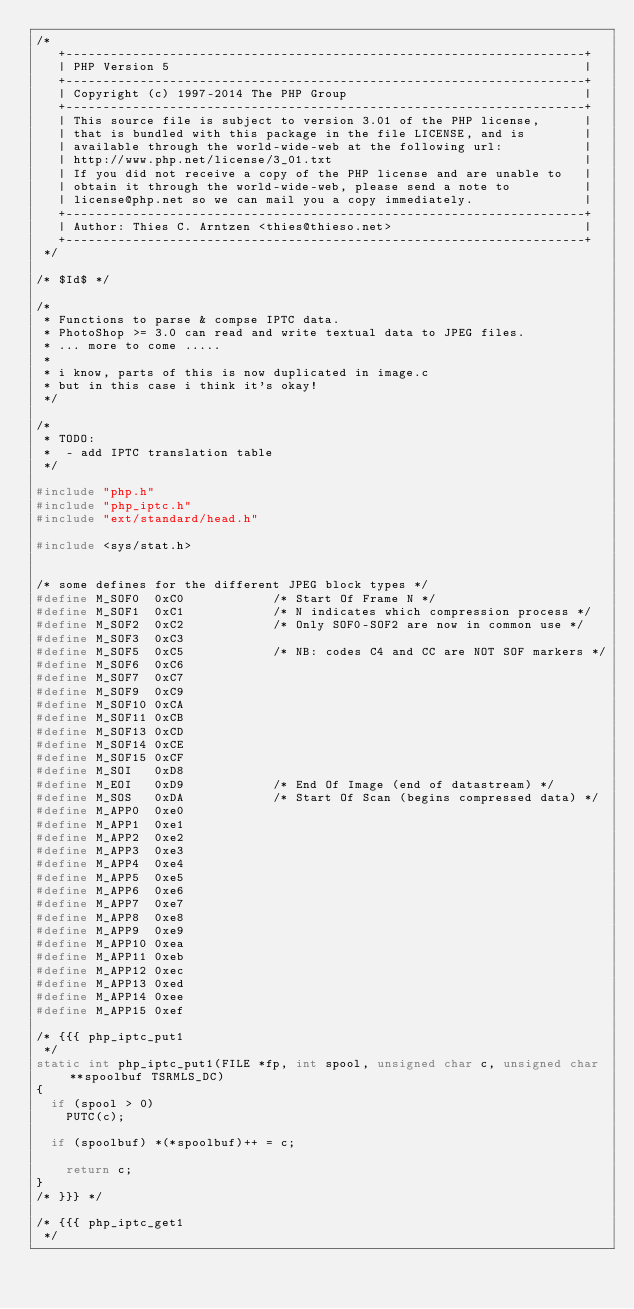Convert code to text. <code><loc_0><loc_0><loc_500><loc_500><_C_>/*
   +----------------------------------------------------------------------+
   | PHP Version 5                                                        |
   +----------------------------------------------------------------------+
   | Copyright (c) 1997-2014 The PHP Group                                |
   +----------------------------------------------------------------------+
   | This source file is subject to version 3.01 of the PHP license,      |
   | that is bundled with this package in the file LICENSE, and is        |
   | available through the world-wide-web at the following url:           |
   | http://www.php.net/license/3_01.txt                                  |
   | If you did not receive a copy of the PHP license and are unable to   |
   | obtain it through the world-wide-web, please send a note to          |
   | license@php.net so we can mail you a copy immediately.               |
   +----------------------------------------------------------------------+
   | Author: Thies C. Arntzen <thies@thieso.net>                          |
   +----------------------------------------------------------------------+
 */

/* $Id$ */

/*
 * Functions to parse & compse IPTC data.
 * PhotoShop >= 3.0 can read and write textual data to JPEG files.
 * ... more to come .....
 * 
 * i know, parts of this is now duplicated in image.c 
 * but in this case i think it's okay!
 */

/*
 * TODO:
 *  - add IPTC translation table
 */
 
#include "php.h"
#include "php_iptc.h"
#include "ext/standard/head.h"

#include <sys/stat.h>


/* some defines for the different JPEG block types */
#define M_SOF0  0xC0            /* Start Of Frame N */
#define M_SOF1  0xC1            /* N indicates which compression process */
#define M_SOF2  0xC2            /* Only SOF0-SOF2 are now in common use */
#define M_SOF3  0xC3
#define M_SOF5  0xC5            /* NB: codes C4 and CC are NOT SOF markers */
#define M_SOF6  0xC6
#define M_SOF7  0xC7
#define M_SOF9  0xC9
#define M_SOF10 0xCA
#define M_SOF11 0xCB
#define M_SOF13 0xCD
#define M_SOF14 0xCE
#define M_SOF15 0xCF
#define M_SOI   0xD8
#define M_EOI   0xD9            /* End Of Image (end of datastream) */
#define M_SOS   0xDA            /* Start Of Scan (begins compressed data) */
#define M_APP0  0xe0
#define M_APP1  0xe1
#define M_APP2  0xe2
#define M_APP3  0xe3
#define M_APP4  0xe4
#define M_APP5  0xe5
#define M_APP6  0xe6
#define M_APP7  0xe7
#define M_APP8  0xe8
#define M_APP9  0xe9
#define M_APP10 0xea
#define M_APP11 0xeb
#define M_APP12 0xec
#define M_APP13 0xed
#define M_APP14 0xee
#define M_APP15 0xef

/* {{{ php_iptc_put1
 */
static int php_iptc_put1(FILE *fp, int spool, unsigned char c, unsigned char **spoolbuf TSRMLS_DC)
{ 
	if (spool > 0)
		PUTC(c);

	if (spoolbuf) *(*spoolbuf)++ = c;

  	return c;
}
/* }}} */

/* {{{ php_iptc_get1
 */</code> 